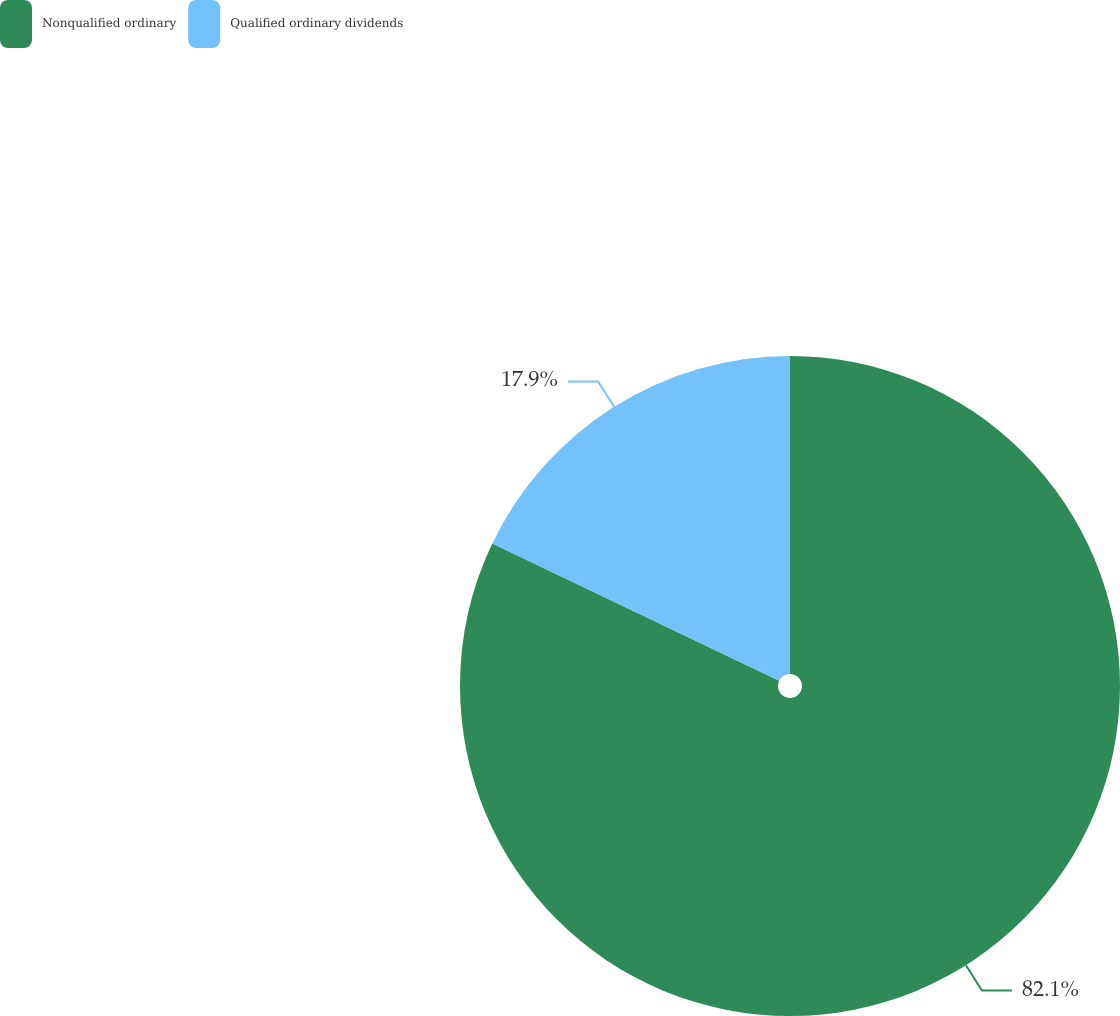<chart> <loc_0><loc_0><loc_500><loc_500><pie_chart><fcel>Nonqualified ordinary<fcel>Qualified ordinary dividends<nl><fcel>82.1%<fcel>17.9%<nl></chart> 